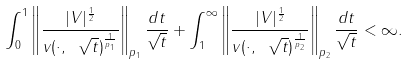<formula> <loc_0><loc_0><loc_500><loc_500>\int _ { 0 } ^ { 1 } \left \| \frac { | V | ^ { \frac { 1 } { 2 } } } { v ( \cdot , \ \sqrt { t } ) ^ { \frac { 1 } { p _ { 1 } } } } \right \| _ { p _ { 1 } } \frac { d t } { \sqrt { t } } + \int _ { 1 } ^ { \infty } \left \| \frac { | V | ^ { \frac { 1 } { 2 } } } { v ( \cdot , \ \sqrt { t } ) ^ { \frac { 1 } { p _ { 2 } } } } \right \| _ { p _ { 2 } } \frac { d t } { \sqrt { t } } < \infty .</formula> 